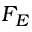<formula> <loc_0><loc_0><loc_500><loc_500>F _ { E }</formula> 